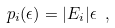Convert formula to latex. <formula><loc_0><loc_0><loc_500><loc_500>p _ { i } ( \epsilon ) = | E _ { i } | \epsilon \ ,</formula> 